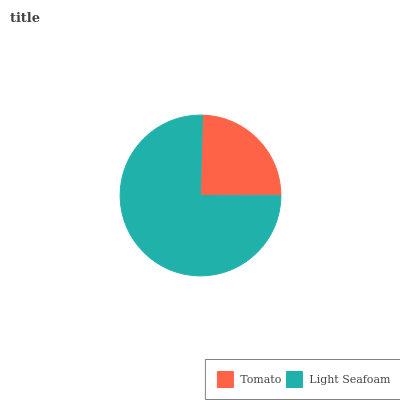Is Tomato the minimum?
Answer yes or no. Yes. Is Light Seafoam the maximum?
Answer yes or no. Yes. Is Light Seafoam the minimum?
Answer yes or no. No. Is Light Seafoam greater than Tomato?
Answer yes or no. Yes. Is Tomato less than Light Seafoam?
Answer yes or no. Yes. Is Tomato greater than Light Seafoam?
Answer yes or no. No. Is Light Seafoam less than Tomato?
Answer yes or no. No. Is Light Seafoam the high median?
Answer yes or no. Yes. Is Tomato the low median?
Answer yes or no. Yes. Is Tomato the high median?
Answer yes or no. No. Is Light Seafoam the low median?
Answer yes or no. No. 